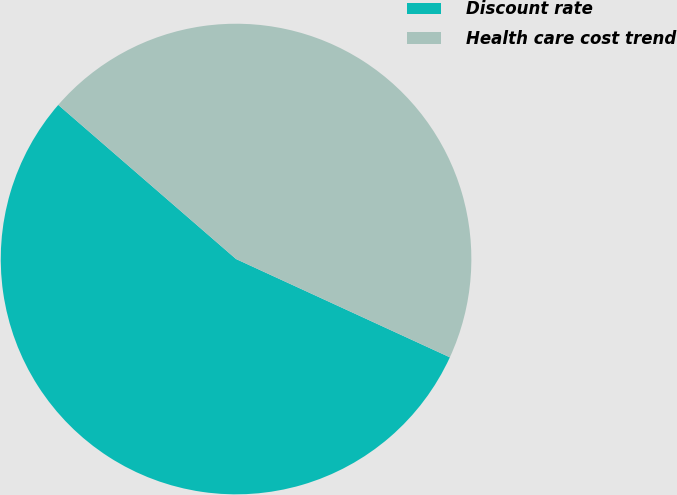Convert chart to OTSL. <chart><loc_0><loc_0><loc_500><loc_500><pie_chart><fcel>Discount rate<fcel>Health care cost trend<nl><fcel>54.51%<fcel>45.49%<nl></chart> 